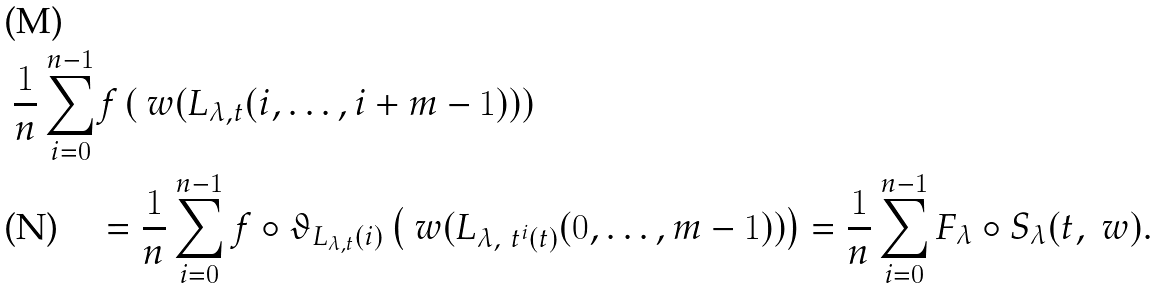Convert formula to latex. <formula><loc_0><loc_0><loc_500><loc_500>\frac { 1 } { n } \sum _ { i = 0 } ^ { n - 1 } & f \left ( \ w ( L _ { \lambda , t } ( i , \dots , i + m - 1 ) ) \right ) \\ & = \frac { 1 } { n } \sum _ { i = 0 } ^ { n - 1 } f \circ \vartheta _ { L _ { \lambda , t } ( i ) } \left ( \ w ( L _ { \lambda , \ t ^ { i } ( t ) } ( 0 , \dots , m - 1 ) ) \right ) = \frac { 1 } { n } \sum _ { i = 0 } ^ { n - 1 } F _ { \lambda } \circ S _ { \lambda } ( t , \ w ) .</formula> 